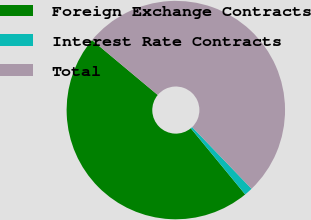<chart> <loc_0><loc_0><loc_500><loc_500><pie_chart><fcel>Foreign Exchange Contracts<fcel>Interest Rate Contracts<fcel>Total<nl><fcel>47.03%<fcel>1.24%<fcel>51.73%<nl></chart> 